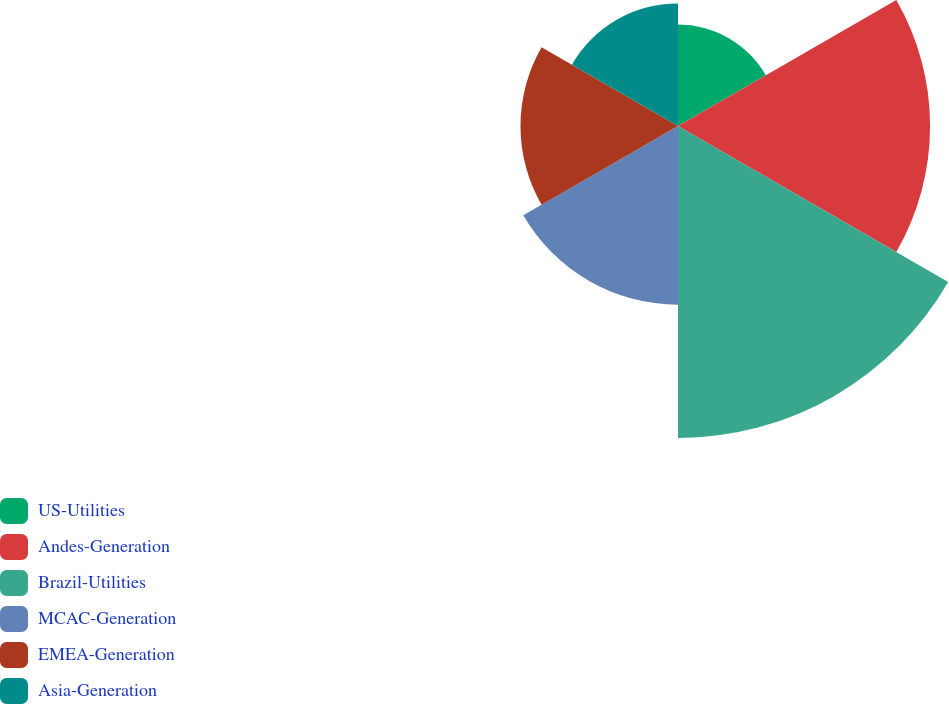Convert chart. <chart><loc_0><loc_0><loc_500><loc_500><pie_chart><fcel>US-Utilities<fcel>Andes-Generation<fcel>Brazil-Utilities<fcel>MCAC-Generation<fcel>EMEA-Generation<fcel>Asia-Generation<nl><fcel>9.02%<fcel>22.42%<fcel>27.75%<fcel>15.89%<fcel>14.01%<fcel>10.9%<nl></chart> 